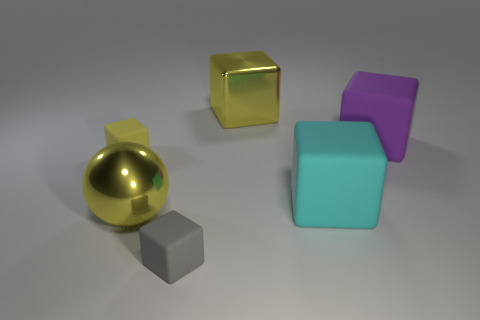What number of other things are there of the same color as the shiny cube?
Give a very brief answer. 2. What number of cubes are left of the purple cube and behind the big yellow sphere?
Ensure brevity in your answer.  3. The big purple thing has what shape?
Offer a terse response. Cube. How many other things are there of the same material as the large purple object?
Keep it short and to the point. 3. There is a shiny thing that is on the left side of the tiny object that is on the right side of the yellow cube in front of the large yellow cube; what color is it?
Your answer should be very brief. Yellow. There is a yellow block that is the same size as the cyan object; what material is it?
Keep it short and to the point. Metal. What number of objects are either objects left of the big cyan cube or big brown metal cubes?
Offer a very short reply. 4. Is there a tiny gray ball?
Provide a succinct answer. No. There is a cube left of the big yellow ball; what is its material?
Provide a succinct answer. Rubber. What material is the tiny cube that is the same color as the large sphere?
Make the answer very short. Rubber. 